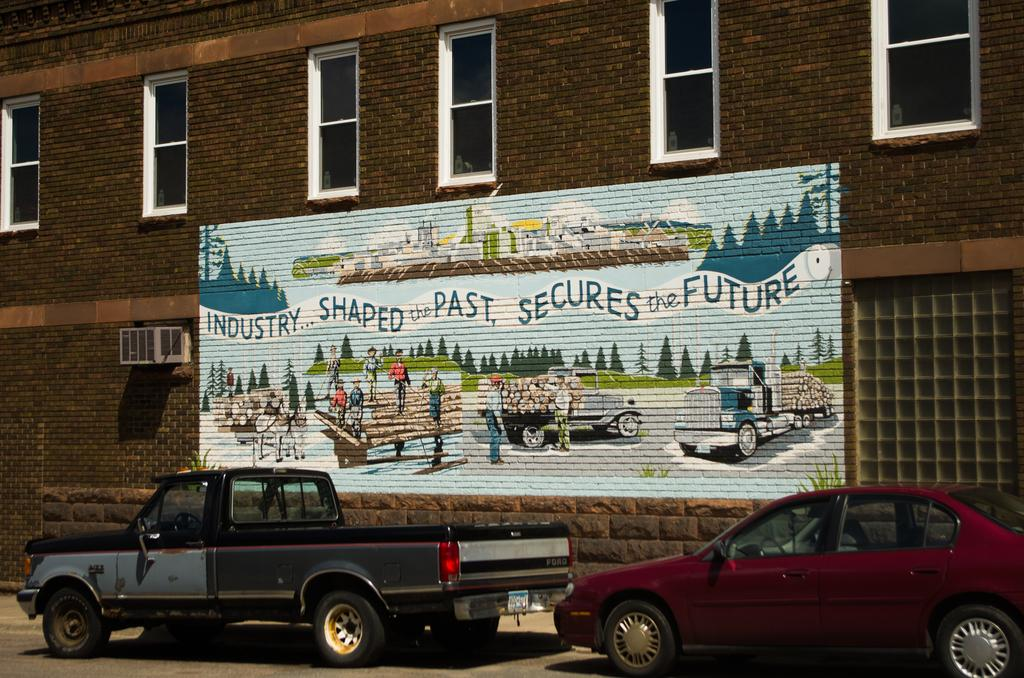What is depicted on the wall in the image? There is an art piece on the wall in the image. What can be seen at the top of the image? There are windows at the top of the image. What is visible at the bottom of the image? There are vehicles at the bottom of the image. What type of chain can be seen hanging from the art piece in the image? There is no chain present in the image; the art piece is depicted on the wall without any visible chains. Is there any snow visible in the image? No, there is no snow present in the image. 